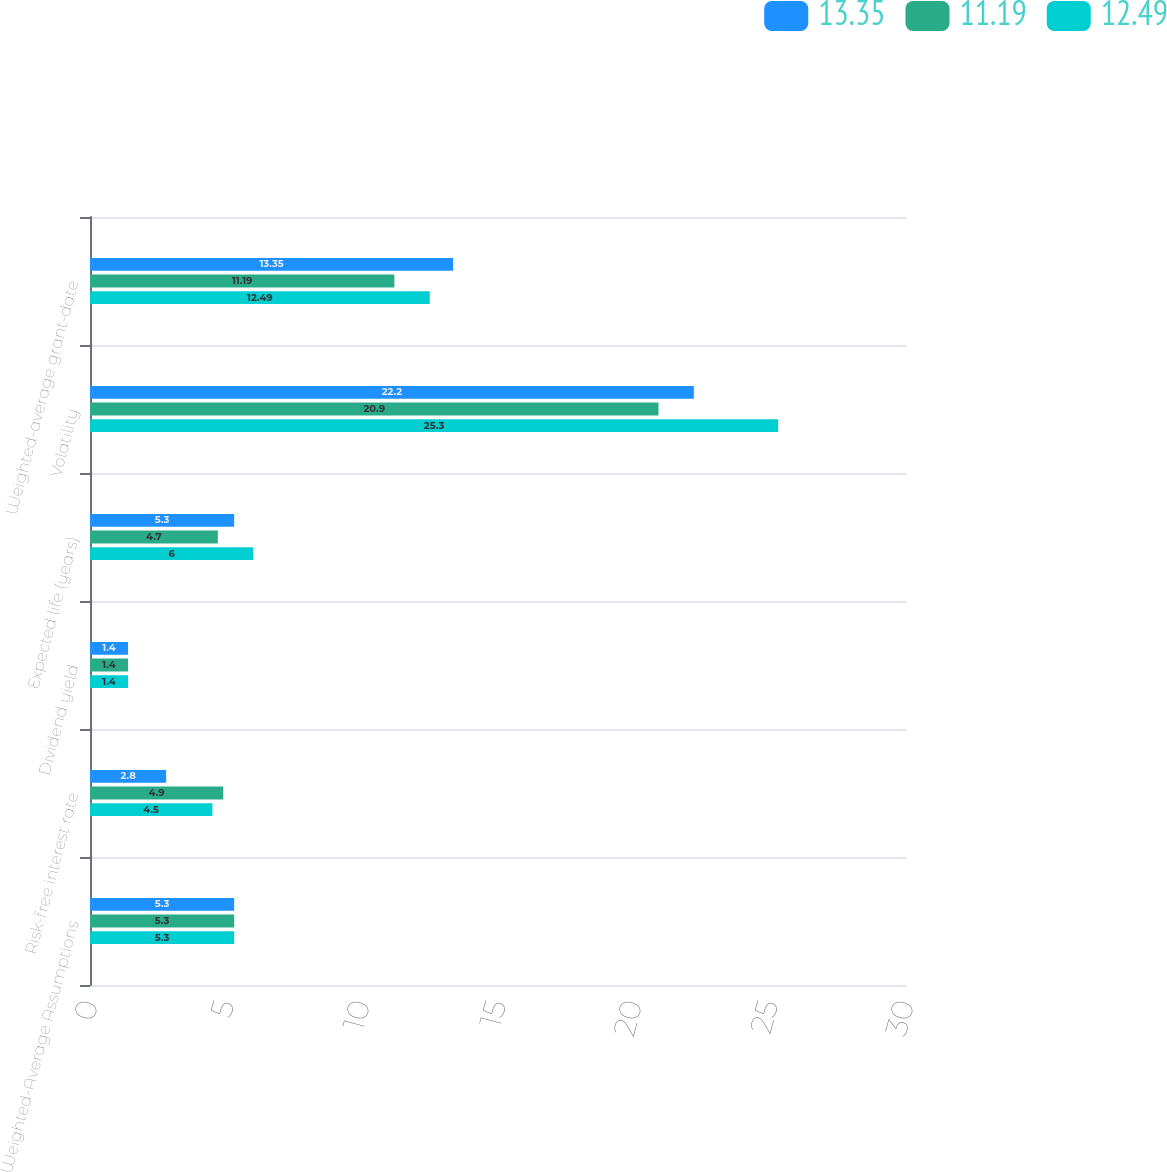<chart> <loc_0><loc_0><loc_500><loc_500><stacked_bar_chart><ecel><fcel>Weighted-Average Assumptions<fcel>Risk-free interest rate<fcel>Dividend yield<fcel>Expected life (years)<fcel>Volatility<fcel>Weighted-average grant-date<nl><fcel>13.35<fcel>5.3<fcel>2.8<fcel>1.4<fcel>5.3<fcel>22.2<fcel>13.35<nl><fcel>11.19<fcel>5.3<fcel>4.9<fcel>1.4<fcel>4.7<fcel>20.9<fcel>11.19<nl><fcel>12.49<fcel>5.3<fcel>4.5<fcel>1.4<fcel>6<fcel>25.3<fcel>12.49<nl></chart> 